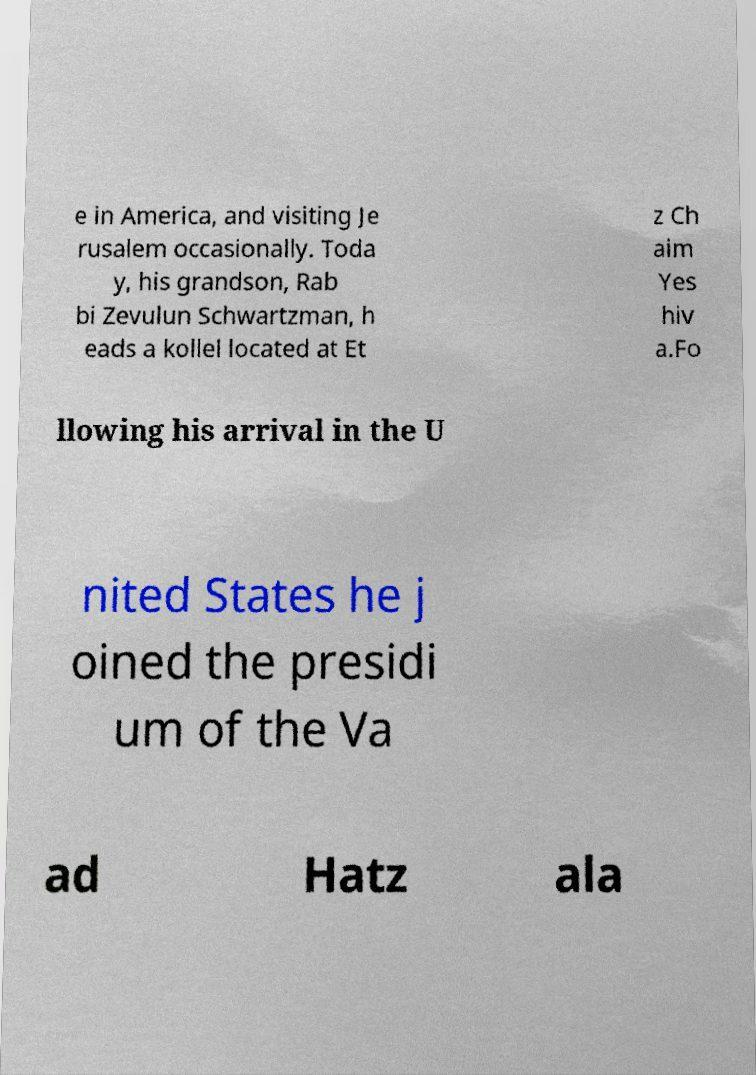Can you accurately transcribe the text from the provided image for me? e in America, and visiting Je rusalem occasionally. Toda y, his grandson, Rab bi Zevulun Schwartzman, h eads a kollel located at Et z Ch aim Yes hiv a.Fo llowing his arrival in the U nited States he j oined the presidi um of the Va ad Hatz ala 